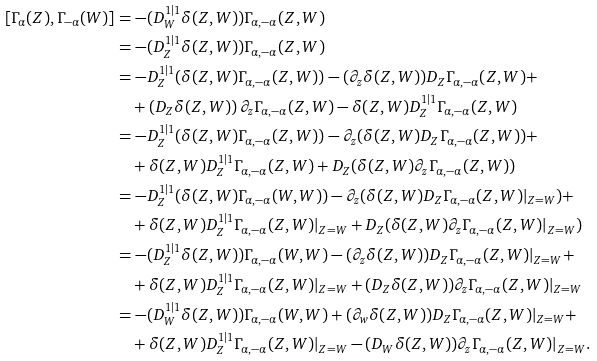Convert formula to latex. <formula><loc_0><loc_0><loc_500><loc_500>{ [ \Gamma _ { \alpha } ( Z ) } , \Gamma _ { - \alpha } ( W ) ] & = - ( D _ { W } ^ { 1 | 1 } \delta ( Z , W ) ) \Gamma _ { \alpha , - \alpha } ( Z , W ) \\ & = - ( D _ { Z } ^ { 1 | 1 } \delta ( Z , W ) ) \Gamma _ { \alpha , - \alpha } ( Z , W ) \\ & = - D _ { Z } ^ { 1 | 1 } ( \delta ( Z , W ) \Gamma _ { \alpha , - \alpha } ( Z , W ) ) - ( \partial _ { z } \delta ( Z , W ) ) D _ { Z } \Gamma _ { \alpha , - \alpha } ( Z , W ) + \\ & \quad + \left ( D _ { Z } \delta ( Z , W ) \right ) \partial _ { z } \Gamma _ { \alpha , - \alpha } ( Z , W ) - \delta ( Z , W ) D _ { Z } ^ { 1 | 1 } \Gamma _ { \alpha , - \alpha } ( Z , W ) \\ & = - D _ { Z } ^ { 1 | 1 } ( \delta ( Z , W ) \Gamma _ { \alpha , - \alpha } ( Z , W ) ) - \partial _ { z } ( \delta ( Z , W ) D _ { Z } \Gamma _ { \alpha , - \alpha } ( Z , W ) ) + \\ & \quad + \delta ( Z , W ) D _ { Z } ^ { 1 | 1 } \Gamma _ { \alpha , - \alpha } ( Z , W ) + D _ { Z } ( \delta ( Z , W ) \partial _ { z } \Gamma _ { \alpha , - \alpha } ( Z , W ) ) \\ & = - D _ { Z } ^ { 1 | 1 } ( \delta ( Z , W ) \Gamma _ { \alpha , - \alpha } ( W , W ) ) - \partial _ { z } ( \delta ( Z , W ) D _ { Z } \Gamma _ { \alpha , - \alpha } ( Z , W ) | _ { Z = W } ) + \\ & \quad + \delta ( Z , W ) D _ { Z } ^ { 1 | 1 } \Gamma _ { \alpha , - \alpha } ( Z , W ) | _ { Z = W } + D _ { Z } ( \delta ( Z , W ) \partial _ { z } \Gamma _ { \alpha , - \alpha } ( Z , W ) | _ { Z = W } ) \\ & = - ( D _ { Z } ^ { 1 | 1 } \delta ( Z , W ) ) \Gamma _ { \alpha , - \alpha } ( W , W ) - ( \partial _ { z } \delta ( Z , W ) ) D _ { Z } \Gamma _ { \alpha , - \alpha } ( Z , W ) | _ { Z = W } + \\ & \quad + \delta ( Z , W ) D _ { Z } ^ { 1 | 1 } \Gamma _ { \alpha , - \alpha } ( Z , W ) | _ { Z = W } + ( D _ { Z } \delta ( Z , W ) ) \partial _ { z } \Gamma _ { \alpha , - \alpha } ( Z , W ) | _ { Z = W } \\ & = - ( D _ { W } ^ { 1 | 1 } \delta ( Z , W ) ) \Gamma _ { \alpha , - \alpha } ( W , W ) + ( \partial _ { w } \delta ( Z , W ) ) D _ { Z } \Gamma _ { \alpha , - \alpha } ( Z , W ) | _ { Z = W } + \\ & \quad + \delta ( Z , W ) D _ { Z } ^ { 1 | 1 } \Gamma _ { \alpha , - \alpha } ( Z , W ) | _ { Z = W } - ( D _ { W } \delta ( Z , W ) ) \partial _ { z } \Gamma _ { \alpha , - \alpha } ( Z , W ) | _ { Z = W } .</formula> 